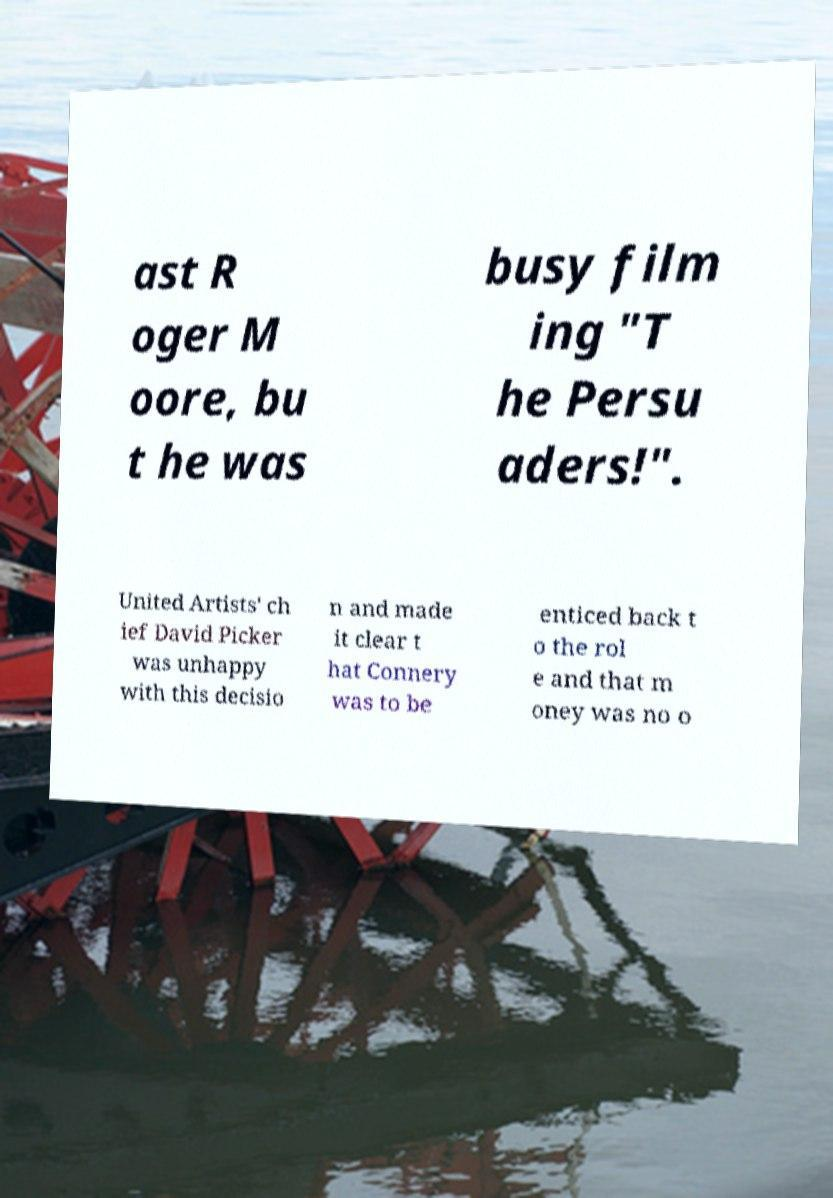Can you accurately transcribe the text from the provided image for me? ast R oger M oore, bu t he was busy film ing "T he Persu aders!". United Artists' ch ief David Picker was unhappy with this decisio n and made it clear t hat Connery was to be enticed back t o the rol e and that m oney was no o 